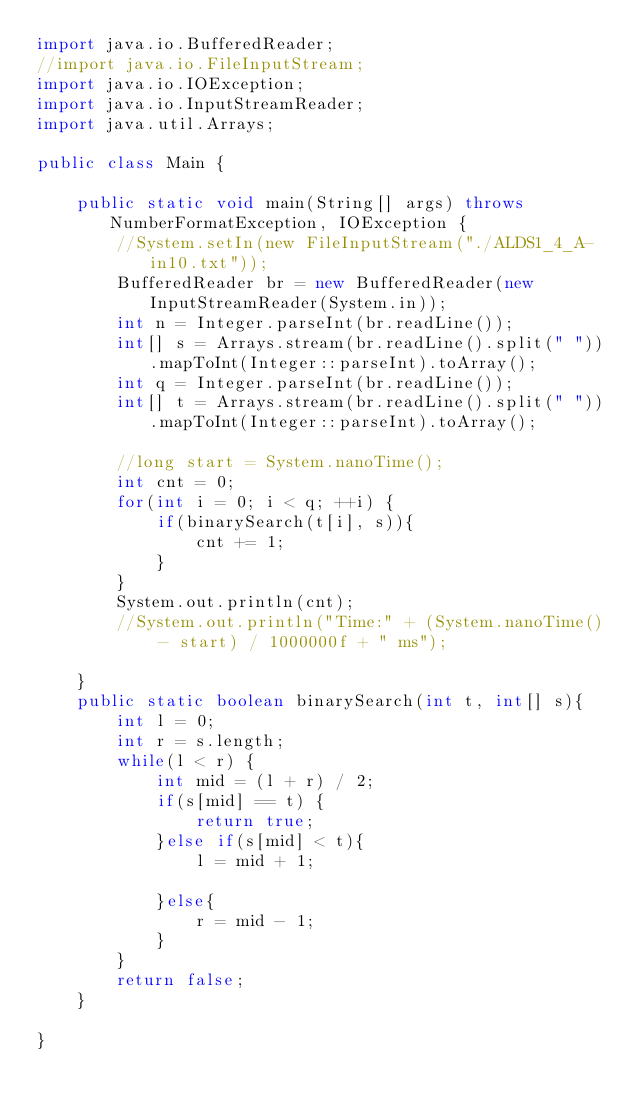<code> <loc_0><loc_0><loc_500><loc_500><_Java_>import java.io.BufferedReader;
//import java.io.FileInputStream;
import java.io.IOException;
import java.io.InputStreamReader;
import java.util.Arrays;

public class Main {

	public static void main(String[] args) throws NumberFormatException, IOException {
		//System.setIn(new FileInputStream("./ALDS1_4_A-in10.txt"));
		BufferedReader br = new BufferedReader(new InputStreamReader(System.in));
		int n = Integer.parseInt(br.readLine());
		int[] s = Arrays.stream(br.readLine().split(" ")).mapToInt(Integer::parseInt).toArray();
		int q = Integer.parseInt(br.readLine());
		int[] t = Arrays.stream(br.readLine().split(" ")).mapToInt(Integer::parseInt).toArray();
		
		//long start = System.nanoTime();
		int cnt = 0;
		for(int i = 0; i < q; ++i) {
			if(binarySearch(t[i], s)){
				cnt += 1;
			}
		}
		System.out.println(cnt);
		//System.out.println("Time:" + (System.nanoTime() - start) / 1000000f + " ms");

	}
	public static boolean binarySearch(int t, int[] s){
		int l = 0;
		int r = s.length;
		while(l < r) {
			int mid = (l + r) / 2;
			if(s[mid] == t) {
				return true;
			}else if(s[mid] < t){
				l = mid + 1;
			
			}else{
				r = mid - 1;
			}
		}
		return false;
	}

}</code> 